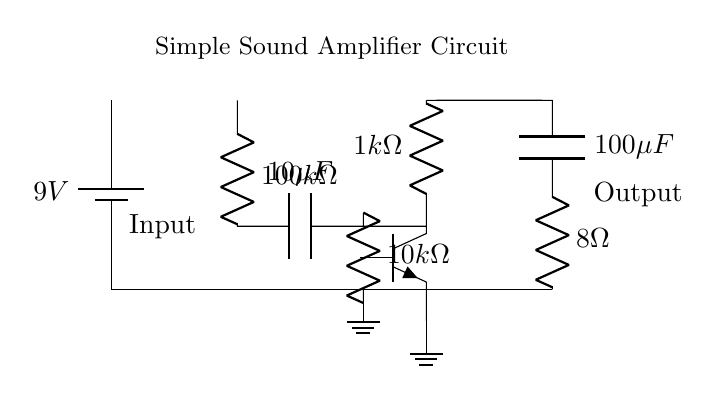What is the voltage of the power supply? The circuit shows a battery labeled with a voltage of 9V next to it, which indicates the power supply voltage.
Answer: 9V What is the resistance of the input resistor? The circuit diagram labels a resistor with a value of 100k ohms connected at the input stage, indicating that this is the input resistor's resistance.
Answer: 100k ohms How many capacitors are present in this circuit? The circuit diagram shows two capacitors, one labeled with 10 microfarads and the other with 100 microfarads, confirming that there are two capacitors.
Answer: 2 What type of transistor is used in this circuit? The diagram features a component labeled npn, which identifies the type of transistor used.
Answer: npn What is the output impedance of the speaker? The circuit indicates a resistor labeled with a value of 8 ohms, which is connected to the output stage, representing the output impedance of the speaker.
Answer: 8 ohms What is the function of the feedback resistor? The feedback resistor, labeled with a value of 1k ohms, connects from the collector to the base of the npn transistor, indicating its role in stabilizing the amplifier's gain.
Answer: Stabilizing gain What happens to the audio signal in this circuit? The audio signal enters at the input, is amplified by the transistor, and exits at the output; this describes the overall function of the circuit.
Answer: It is amplified 